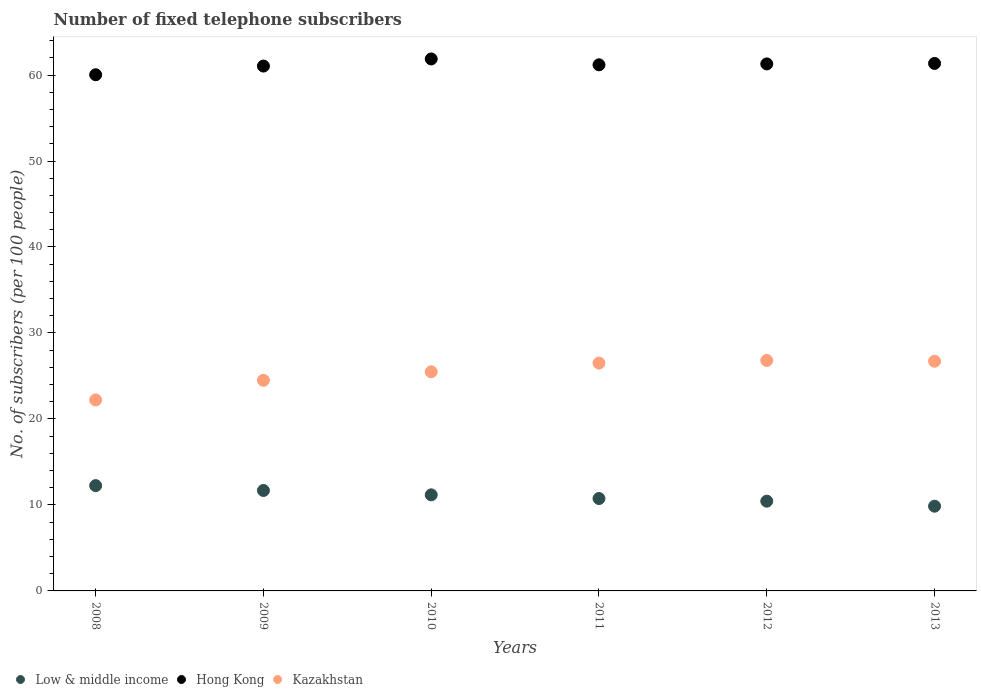What is the number of fixed telephone subscribers in Kazakhstan in 2013?
Your response must be concise. 26.71. Across all years, what is the maximum number of fixed telephone subscribers in Kazakhstan?
Give a very brief answer. 26.8. Across all years, what is the minimum number of fixed telephone subscribers in Kazakhstan?
Provide a succinct answer. 22.21. In which year was the number of fixed telephone subscribers in Low & middle income maximum?
Make the answer very short. 2008. In which year was the number of fixed telephone subscribers in Hong Kong minimum?
Your answer should be compact. 2008. What is the total number of fixed telephone subscribers in Low & middle income in the graph?
Your answer should be very brief. 66.14. What is the difference between the number of fixed telephone subscribers in Low & middle income in 2008 and that in 2009?
Provide a succinct answer. 0.57. What is the difference between the number of fixed telephone subscribers in Hong Kong in 2009 and the number of fixed telephone subscribers in Kazakhstan in 2012?
Make the answer very short. 34.24. What is the average number of fixed telephone subscribers in Low & middle income per year?
Your response must be concise. 11.02. In the year 2008, what is the difference between the number of fixed telephone subscribers in Low & middle income and number of fixed telephone subscribers in Hong Kong?
Provide a succinct answer. -47.79. In how many years, is the number of fixed telephone subscribers in Hong Kong greater than 28?
Your answer should be compact. 6. What is the ratio of the number of fixed telephone subscribers in Hong Kong in 2010 to that in 2013?
Make the answer very short. 1.01. Is the number of fixed telephone subscribers in Hong Kong in 2008 less than that in 2012?
Give a very brief answer. Yes. Is the difference between the number of fixed telephone subscribers in Low & middle income in 2008 and 2013 greater than the difference between the number of fixed telephone subscribers in Hong Kong in 2008 and 2013?
Ensure brevity in your answer.  Yes. What is the difference between the highest and the second highest number of fixed telephone subscribers in Hong Kong?
Your answer should be very brief. 0.52. What is the difference between the highest and the lowest number of fixed telephone subscribers in Hong Kong?
Your answer should be compact. 1.84. In how many years, is the number of fixed telephone subscribers in Hong Kong greater than the average number of fixed telephone subscribers in Hong Kong taken over all years?
Provide a short and direct response. 4. Is the number of fixed telephone subscribers in Hong Kong strictly greater than the number of fixed telephone subscribers in Low & middle income over the years?
Your answer should be compact. Yes. Are the values on the major ticks of Y-axis written in scientific E-notation?
Offer a very short reply. No. Where does the legend appear in the graph?
Your answer should be compact. Bottom left. What is the title of the graph?
Provide a short and direct response. Number of fixed telephone subscribers. Does "United States" appear as one of the legend labels in the graph?
Your response must be concise. No. What is the label or title of the Y-axis?
Provide a short and direct response. No. of subscribers (per 100 people). What is the No. of subscribers (per 100 people) of Low & middle income in 2008?
Give a very brief answer. 12.25. What is the No. of subscribers (per 100 people) of Hong Kong in 2008?
Give a very brief answer. 60.03. What is the No. of subscribers (per 100 people) in Kazakhstan in 2008?
Offer a very short reply. 22.21. What is the No. of subscribers (per 100 people) of Low & middle income in 2009?
Provide a succinct answer. 11.68. What is the No. of subscribers (per 100 people) in Hong Kong in 2009?
Your answer should be compact. 61.04. What is the No. of subscribers (per 100 people) of Kazakhstan in 2009?
Offer a terse response. 24.5. What is the No. of subscribers (per 100 people) of Low & middle income in 2010?
Keep it short and to the point. 11.17. What is the No. of subscribers (per 100 people) of Hong Kong in 2010?
Make the answer very short. 61.87. What is the No. of subscribers (per 100 people) of Kazakhstan in 2010?
Keep it short and to the point. 25.49. What is the No. of subscribers (per 100 people) in Low & middle income in 2011?
Keep it short and to the point. 10.75. What is the No. of subscribers (per 100 people) in Hong Kong in 2011?
Offer a very short reply. 61.19. What is the No. of subscribers (per 100 people) in Kazakhstan in 2011?
Your answer should be compact. 26.5. What is the No. of subscribers (per 100 people) in Low & middle income in 2012?
Offer a terse response. 10.44. What is the No. of subscribers (per 100 people) in Hong Kong in 2012?
Offer a terse response. 61.29. What is the No. of subscribers (per 100 people) in Kazakhstan in 2012?
Your response must be concise. 26.8. What is the No. of subscribers (per 100 people) in Low & middle income in 2013?
Offer a very short reply. 9.85. What is the No. of subscribers (per 100 people) of Hong Kong in 2013?
Make the answer very short. 61.35. What is the No. of subscribers (per 100 people) of Kazakhstan in 2013?
Your answer should be very brief. 26.71. Across all years, what is the maximum No. of subscribers (per 100 people) of Low & middle income?
Keep it short and to the point. 12.25. Across all years, what is the maximum No. of subscribers (per 100 people) of Hong Kong?
Make the answer very short. 61.87. Across all years, what is the maximum No. of subscribers (per 100 people) in Kazakhstan?
Give a very brief answer. 26.8. Across all years, what is the minimum No. of subscribers (per 100 people) in Low & middle income?
Keep it short and to the point. 9.85. Across all years, what is the minimum No. of subscribers (per 100 people) in Hong Kong?
Provide a succinct answer. 60.03. Across all years, what is the minimum No. of subscribers (per 100 people) of Kazakhstan?
Your answer should be very brief. 22.21. What is the total No. of subscribers (per 100 people) in Low & middle income in the graph?
Offer a very short reply. 66.14. What is the total No. of subscribers (per 100 people) of Hong Kong in the graph?
Provide a succinct answer. 366.78. What is the total No. of subscribers (per 100 people) of Kazakhstan in the graph?
Ensure brevity in your answer.  152.21. What is the difference between the No. of subscribers (per 100 people) in Low & middle income in 2008 and that in 2009?
Provide a succinct answer. 0.57. What is the difference between the No. of subscribers (per 100 people) of Hong Kong in 2008 and that in 2009?
Make the answer very short. -1.01. What is the difference between the No. of subscribers (per 100 people) of Kazakhstan in 2008 and that in 2009?
Make the answer very short. -2.28. What is the difference between the No. of subscribers (per 100 people) of Low & middle income in 2008 and that in 2010?
Provide a succinct answer. 1.07. What is the difference between the No. of subscribers (per 100 people) of Hong Kong in 2008 and that in 2010?
Give a very brief answer. -1.84. What is the difference between the No. of subscribers (per 100 people) in Kazakhstan in 2008 and that in 2010?
Your answer should be compact. -3.27. What is the difference between the No. of subscribers (per 100 people) in Low & middle income in 2008 and that in 2011?
Your response must be concise. 1.5. What is the difference between the No. of subscribers (per 100 people) in Hong Kong in 2008 and that in 2011?
Make the answer very short. -1.16. What is the difference between the No. of subscribers (per 100 people) of Kazakhstan in 2008 and that in 2011?
Provide a succinct answer. -4.28. What is the difference between the No. of subscribers (per 100 people) of Low & middle income in 2008 and that in 2012?
Offer a very short reply. 1.81. What is the difference between the No. of subscribers (per 100 people) in Hong Kong in 2008 and that in 2012?
Give a very brief answer. -1.26. What is the difference between the No. of subscribers (per 100 people) in Kazakhstan in 2008 and that in 2012?
Keep it short and to the point. -4.59. What is the difference between the No. of subscribers (per 100 people) of Low & middle income in 2008 and that in 2013?
Provide a short and direct response. 2.39. What is the difference between the No. of subscribers (per 100 people) in Hong Kong in 2008 and that in 2013?
Offer a very short reply. -1.32. What is the difference between the No. of subscribers (per 100 people) of Kazakhstan in 2008 and that in 2013?
Your response must be concise. -4.5. What is the difference between the No. of subscribers (per 100 people) of Low & middle income in 2009 and that in 2010?
Your response must be concise. 0.51. What is the difference between the No. of subscribers (per 100 people) of Hong Kong in 2009 and that in 2010?
Provide a succinct answer. -0.83. What is the difference between the No. of subscribers (per 100 people) of Kazakhstan in 2009 and that in 2010?
Keep it short and to the point. -0.99. What is the difference between the No. of subscribers (per 100 people) of Low & middle income in 2009 and that in 2011?
Your response must be concise. 0.93. What is the difference between the No. of subscribers (per 100 people) in Hong Kong in 2009 and that in 2011?
Provide a succinct answer. -0.15. What is the difference between the No. of subscribers (per 100 people) of Kazakhstan in 2009 and that in 2011?
Keep it short and to the point. -2. What is the difference between the No. of subscribers (per 100 people) of Low & middle income in 2009 and that in 2012?
Offer a terse response. 1.24. What is the difference between the No. of subscribers (per 100 people) of Hong Kong in 2009 and that in 2012?
Your answer should be very brief. -0.25. What is the difference between the No. of subscribers (per 100 people) in Kazakhstan in 2009 and that in 2012?
Your response must be concise. -2.31. What is the difference between the No. of subscribers (per 100 people) in Low & middle income in 2009 and that in 2013?
Offer a very short reply. 1.83. What is the difference between the No. of subscribers (per 100 people) of Hong Kong in 2009 and that in 2013?
Give a very brief answer. -0.3. What is the difference between the No. of subscribers (per 100 people) of Kazakhstan in 2009 and that in 2013?
Provide a short and direct response. -2.22. What is the difference between the No. of subscribers (per 100 people) in Low & middle income in 2010 and that in 2011?
Your answer should be very brief. 0.43. What is the difference between the No. of subscribers (per 100 people) of Hong Kong in 2010 and that in 2011?
Give a very brief answer. 0.68. What is the difference between the No. of subscribers (per 100 people) of Kazakhstan in 2010 and that in 2011?
Ensure brevity in your answer.  -1.01. What is the difference between the No. of subscribers (per 100 people) of Low & middle income in 2010 and that in 2012?
Keep it short and to the point. 0.73. What is the difference between the No. of subscribers (per 100 people) of Hong Kong in 2010 and that in 2012?
Offer a terse response. 0.58. What is the difference between the No. of subscribers (per 100 people) in Kazakhstan in 2010 and that in 2012?
Your response must be concise. -1.32. What is the difference between the No. of subscribers (per 100 people) of Low & middle income in 2010 and that in 2013?
Offer a terse response. 1.32. What is the difference between the No. of subscribers (per 100 people) of Hong Kong in 2010 and that in 2013?
Provide a succinct answer. 0.52. What is the difference between the No. of subscribers (per 100 people) of Kazakhstan in 2010 and that in 2013?
Provide a succinct answer. -1.23. What is the difference between the No. of subscribers (per 100 people) of Low & middle income in 2011 and that in 2012?
Offer a terse response. 0.31. What is the difference between the No. of subscribers (per 100 people) of Hong Kong in 2011 and that in 2012?
Offer a very short reply. -0.1. What is the difference between the No. of subscribers (per 100 people) of Kazakhstan in 2011 and that in 2012?
Provide a short and direct response. -0.31. What is the difference between the No. of subscribers (per 100 people) of Low & middle income in 2011 and that in 2013?
Provide a succinct answer. 0.89. What is the difference between the No. of subscribers (per 100 people) in Hong Kong in 2011 and that in 2013?
Make the answer very short. -0.16. What is the difference between the No. of subscribers (per 100 people) of Kazakhstan in 2011 and that in 2013?
Offer a very short reply. -0.22. What is the difference between the No. of subscribers (per 100 people) of Low & middle income in 2012 and that in 2013?
Keep it short and to the point. 0.58. What is the difference between the No. of subscribers (per 100 people) of Hong Kong in 2012 and that in 2013?
Your answer should be compact. -0.05. What is the difference between the No. of subscribers (per 100 people) of Kazakhstan in 2012 and that in 2013?
Provide a succinct answer. 0.09. What is the difference between the No. of subscribers (per 100 people) in Low & middle income in 2008 and the No. of subscribers (per 100 people) in Hong Kong in 2009?
Your answer should be compact. -48.8. What is the difference between the No. of subscribers (per 100 people) in Low & middle income in 2008 and the No. of subscribers (per 100 people) in Kazakhstan in 2009?
Make the answer very short. -12.25. What is the difference between the No. of subscribers (per 100 people) of Hong Kong in 2008 and the No. of subscribers (per 100 people) of Kazakhstan in 2009?
Make the answer very short. 35.54. What is the difference between the No. of subscribers (per 100 people) in Low & middle income in 2008 and the No. of subscribers (per 100 people) in Hong Kong in 2010?
Ensure brevity in your answer.  -49.63. What is the difference between the No. of subscribers (per 100 people) of Low & middle income in 2008 and the No. of subscribers (per 100 people) of Kazakhstan in 2010?
Ensure brevity in your answer.  -13.24. What is the difference between the No. of subscribers (per 100 people) in Hong Kong in 2008 and the No. of subscribers (per 100 people) in Kazakhstan in 2010?
Offer a terse response. 34.55. What is the difference between the No. of subscribers (per 100 people) of Low & middle income in 2008 and the No. of subscribers (per 100 people) of Hong Kong in 2011?
Provide a succinct answer. -48.94. What is the difference between the No. of subscribers (per 100 people) of Low & middle income in 2008 and the No. of subscribers (per 100 people) of Kazakhstan in 2011?
Your answer should be compact. -14.25. What is the difference between the No. of subscribers (per 100 people) of Hong Kong in 2008 and the No. of subscribers (per 100 people) of Kazakhstan in 2011?
Your answer should be compact. 33.53. What is the difference between the No. of subscribers (per 100 people) of Low & middle income in 2008 and the No. of subscribers (per 100 people) of Hong Kong in 2012?
Your answer should be compact. -49.05. What is the difference between the No. of subscribers (per 100 people) of Low & middle income in 2008 and the No. of subscribers (per 100 people) of Kazakhstan in 2012?
Your answer should be very brief. -14.56. What is the difference between the No. of subscribers (per 100 people) of Hong Kong in 2008 and the No. of subscribers (per 100 people) of Kazakhstan in 2012?
Make the answer very short. 33.23. What is the difference between the No. of subscribers (per 100 people) in Low & middle income in 2008 and the No. of subscribers (per 100 people) in Hong Kong in 2013?
Ensure brevity in your answer.  -49.1. What is the difference between the No. of subscribers (per 100 people) of Low & middle income in 2008 and the No. of subscribers (per 100 people) of Kazakhstan in 2013?
Offer a terse response. -14.47. What is the difference between the No. of subscribers (per 100 people) of Hong Kong in 2008 and the No. of subscribers (per 100 people) of Kazakhstan in 2013?
Offer a terse response. 33.32. What is the difference between the No. of subscribers (per 100 people) in Low & middle income in 2009 and the No. of subscribers (per 100 people) in Hong Kong in 2010?
Your response must be concise. -50.19. What is the difference between the No. of subscribers (per 100 people) of Low & middle income in 2009 and the No. of subscribers (per 100 people) of Kazakhstan in 2010?
Provide a succinct answer. -13.8. What is the difference between the No. of subscribers (per 100 people) in Hong Kong in 2009 and the No. of subscribers (per 100 people) in Kazakhstan in 2010?
Provide a short and direct response. 35.56. What is the difference between the No. of subscribers (per 100 people) of Low & middle income in 2009 and the No. of subscribers (per 100 people) of Hong Kong in 2011?
Your answer should be very brief. -49.51. What is the difference between the No. of subscribers (per 100 people) of Low & middle income in 2009 and the No. of subscribers (per 100 people) of Kazakhstan in 2011?
Ensure brevity in your answer.  -14.82. What is the difference between the No. of subscribers (per 100 people) of Hong Kong in 2009 and the No. of subscribers (per 100 people) of Kazakhstan in 2011?
Provide a succinct answer. 34.54. What is the difference between the No. of subscribers (per 100 people) of Low & middle income in 2009 and the No. of subscribers (per 100 people) of Hong Kong in 2012?
Make the answer very short. -49.61. What is the difference between the No. of subscribers (per 100 people) in Low & middle income in 2009 and the No. of subscribers (per 100 people) in Kazakhstan in 2012?
Your answer should be compact. -15.12. What is the difference between the No. of subscribers (per 100 people) of Hong Kong in 2009 and the No. of subscribers (per 100 people) of Kazakhstan in 2012?
Give a very brief answer. 34.24. What is the difference between the No. of subscribers (per 100 people) of Low & middle income in 2009 and the No. of subscribers (per 100 people) of Hong Kong in 2013?
Give a very brief answer. -49.67. What is the difference between the No. of subscribers (per 100 people) of Low & middle income in 2009 and the No. of subscribers (per 100 people) of Kazakhstan in 2013?
Give a very brief answer. -15.03. What is the difference between the No. of subscribers (per 100 people) in Hong Kong in 2009 and the No. of subscribers (per 100 people) in Kazakhstan in 2013?
Ensure brevity in your answer.  34.33. What is the difference between the No. of subscribers (per 100 people) in Low & middle income in 2010 and the No. of subscribers (per 100 people) in Hong Kong in 2011?
Ensure brevity in your answer.  -50.02. What is the difference between the No. of subscribers (per 100 people) of Low & middle income in 2010 and the No. of subscribers (per 100 people) of Kazakhstan in 2011?
Give a very brief answer. -15.32. What is the difference between the No. of subscribers (per 100 people) of Hong Kong in 2010 and the No. of subscribers (per 100 people) of Kazakhstan in 2011?
Make the answer very short. 35.37. What is the difference between the No. of subscribers (per 100 people) of Low & middle income in 2010 and the No. of subscribers (per 100 people) of Hong Kong in 2012?
Make the answer very short. -50.12. What is the difference between the No. of subscribers (per 100 people) of Low & middle income in 2010 and the No. of subscribers (per 100 people) of Kazakhstan in 2012?
Your response must be concise. -15.63. What is the difference between the No. of subscribers (per 100 people) in Hong Kong in 2010 and the No. of subscribers (per 100 people) in Kazakhstan in 2012?
Give a very brief answer. 35.07. What is the difference between the No. of subscribers (per 100 people) in Low & middle income in 2010 and the No. of subscribers (per 100 people) in Hong Kong in 2013?
Your response must be concise. -50.17. What is the difference between the No. of subscribers (per 100 people) in Low & middle income in 2010 and the No. of subscribers (per 100 people) in Kazakhstan in 2013?
Your answer should be very brief. -15.54. What is the difference between the No. of subscribers (per 100 people) in Hong Kong in 2010 and the No. of subscribers (per 100 people) in Kazakhstan in 2013?
Your answer should be very brief. 35.16. What is the difference between the No. of subscribers (per 100 people) in Low & middle income in 2011 and the No. of subscribers (per 100 people) in Hong Kong in 2012?
Your answer should be compact. -50.55. What is the difference between the No. of subscribers (per 100 people) of Low & middle income in 2011 and the No. of subscribers (per 100 people) of Kazakhstan in 2012?
Make the answer very short. -16.06. What is the difference between the No. of subscribers (per 100 people) in Hong Kong in 2011 and the No. of subscribers (per 100 people) in Kazakhstan in 2012?
Your answer should be compact. 34.39. What is the difference between the No. of subscribers (per 100 people) in Low & middle income in 2011 and the No. of subscribers (per 100 people) in Hong Kong in 2013?
Provide a short and direct response. -50.6. What is the difference between the No. of subscribers (per 100 people) in Low & middle income in 2011 and the No. of subscribers (per 100 people) in Kazakhstan in 2013?
Ensure brevity in your answer.  -15.97. What is the difference between the No. of subscribers (per 100 people) of Hong Kong in 2011 and the No. of subscribers (per 100 people) of Kazakhstan in 2013?
Your answer should be very brief. 34.48. What is the difference between the No. of subscribers (per 100 people) of Low & middle income in 2012 and the No. of subscribers (per 100 people) of Hong Kong in 2013?
Your response must be concise. -50.91. What is the difference between the No. of subscribers (per 100 people) of Low & middle income in 2012 and the No. of subscribers (per 100 people) of Kazakhstan in 2013?
Offer a terse response. -16.28. What is the difference between the No. of subscribers (per 100 people) of Hong Kong in 2012 and the No. of subscribers (per 100 people) of Kazakhstan in 2013?
Keep it short and to the point. 34.58. What is the average No. of subscribers (per 100 people) of Low & middle income per year?
Keep it short and to the point. 11.02. What is the average No. of subscribers (per 100 people) in Hong Kong per year?
Provide a succinct answer. 61.13. What is the average No. of subscribers (per 100 people) of Kazakhstan per year?
Make the answer very short. 25.37. In the year 2008, what is the difference between the No. of subscribers (per 100 people) in Low & middle income and No. of subscribers (per 100 people) in Hong Kong?
Offer a very short reply. -47.79. In the year 2008, what is the difference between the No. of subscribers (per 100 people) in Low & middle income and No. of subscribers (per 100 people) in Kazakhstan?
Provide a succinct answer. -9.97. In the year 2008, what is the difference between the No. of subscribers (per 100 people) of Hong Kong and No. of subscribers (per 100 people) of Kazakhstan?
Keep it short and to the point. 37.82. In the year 2009, what is the difference between the No. of subscribers (per 100 people) in Low & middle income and No. of subscribers (per 100 people) in Hong Kong?
Make the answer very short. -49.36. In the year 2009, what is the difference between the No. of subscribers (per 100 people) of Low & middle income and No. of subscribers (per 100 people) of Kazakhstan?
Give a very brief answer. -12.81. In the year 2009, what is the difference between the No. of subscribers (per 100 people) of Hong Kong and No. of subscribers (per 100 people) of Kazakhstan?
Your response must be concise. 36.55. In the year 2010, what is the difference between the No. of subscribers (per 100 people) in Low & middle income and No. of subscribers (per 100 people) in Hong Kong?
Your answer should be very brief. -50.7. In the year 2010, what is the difference between the No. of subscribers (per 100 people) in Low & middle income and No. of subscribers (per 100 people) in Kazakhstan?
Your response must be concise. -14.31. In the year 2010, what is the difference between the No. of subscribers (per 100 people) in Hong Kong and No. of subscribers (per 100 people) in Kazakhstan?
Ensure brevity in your answer.  36.39. In the year 2011, what is the difference between the No. of subscribers (per 100 people) of Low & middle income and No. of subscribers (per 100 people) of Hong Kong?
Offer a terse response. -50.44. In the year 2011, what is the difference between the No. of subscribers (per 100 people) in Low & middle income and No. of subscribers (per 100 people) in Kazakhstan?
Your answer should be very brief. -15.75. In the year 2011, what is the difference between the No. of subscribers (per 100 people) in Hong Kong and No. of subscribers (per 100 people) in Kazakhstan?
Provide a succinct answer. 34.69. In the year 2012, what is the difference between the No. of subscribers (per 100 people) of Low & middle income and No. of subscribers (per 100 people) of Hong Kong?
Your response must be concise. -50.85. In the year 2012, what is the difference between the No. of subscribers (per 100 people) in Low & middle income and No. of subscribers (per 100 people) in Kazakhstan?
Your answer should be very brief. -16.37. In the year 2012, what is the difference between the No. of subscribers (per 100 people) of Hong Kong and No. of subscribers (per 100 people) of Kazakhstan?
Offer a terse response. 34.49. In the year 2013, what is the difference between the No. of subscribers (per 100 people) in Low & middle income and No. of subscribers (per 100 people) in Hong Kong?
Provide a short and direct response. -51.49. In the year 2013, what is the difference between the No. of subscribers (per 100 people) in Low & middle income and No. of subscribers (per 100 people) in Kazakhstan?
Offer a very short reply. -16.86. In the year 2013, what is the difference between the No. of subscribers (per 100 people) of Hong Kong and No. of subscribers (per 100 people) of Kazakhstan?
Your answer should be very brief. 34.63. What is the ratio of the No. of subscribers (per 100 people) in Low & middle income in 2008 to that in 2009?
Offer a very short reply. 1.05. What is the ratio of the No. of subscribers (per 100 people) in Hong Kong in 2008 to that in 2009?
Give a very brief answer. 0.98. What is the ratio of the No. of subscribers (per 100 people) in Kazakhstan in 2008 to that in 2009?
Your answer should be compact. 0.91. What is the ratio of the No. of subscribers (per 100 people) of Low & middle income in 2008 to that in 2010?
Provide a short and direct response. 1.1. What is the ratio of the No. of subscribers (per 100 people) of Hong Kong in 2008 to that in 2010?
Provide a short and direct response. 0.97. What is the ratio of the No. of subscribers (per 100 people) in Kazakhstan in 2008 to that in 2010?
Give a very brief answer. 0.87. What is the ratio of the No. of subscribers (per 100 people) of Low & middle income in 2008 to that in 2011?
Provide a short and direct response. 1.14. What is the ratio of the No. of subscribers (per 100 people) of Hong Kong in 2008 to that in 2011?
Make the answer very short. 0.98. What is the ratio of the No. of subscribers (per 100 people) in Kazakhstan in 2008 to that in 2011?
Ensure brevity in your answer.  0.84. What is the ratio of the No. of subscribers (per 100 people) in Low & middle income in 2008 to that in 2012?
Keep it short and to the point. 1.17. What is the ratio of the No. of subscribers (per 100 people) in Hong Kong in 2008 to that in 2012?
Give a very brief answer. 0.98. What is the ratio of the No. of subscribers (per 100 people) of Kazakhstan in 2008 to that in 2012?
Keep it short and to the point. 0.83. What is the ratio of the No. of subscribers (per 100 people) in Low & middle income in 2008 to that in 2013?
Your answer should be very brief. 1.24. What is the ratio of the No. of subscribers (per 100 people) in Hong Kong in 2008 to that in 2013?
Your answer should be very brief. 0.98. What is the ratio of the No. of subscribers (per 100 people) of Kazakhstan in 2008 to that in 2013?
Make the answer very short. 0.83. What is the ratio of the No. of subscribers (per 100 people) in Low & middle income in 2009 to that in 2010?
Offer a terse response. 1.05. What is the ratio of the No. of subscribers (per 100 people) of Hong Kong in 2009 to that in 2010?
Provide a short and direct response. 0.99. What is the ratio of the No. of subscribers (per 100 people) in Kazakhstan in 2009 to that in 2010?
Your answer should be compact. 0.96. What is the ratio of the No. of subscribers (per 100 people) in Low & middle income in 2009 to that in 2011?
Provide a short and direct response. 1.09. What is the ratio of the No. of subscribers (per 100 people) of Kazakhstan in 2009 to that in 2011?
Make the answer very short. 0.92. What is the ratio of the No. of subscribers (per 100 people) in Low & middle income in 2009 to that in 2012?
Give a very brief answer. 1.12. What is the ratio of the No. of subscribers (per 100 people) in Kazakhstan in 2009 to that in 2012?
Offer a terse response. 0.91. What is the ratio of the No. of subscribers (per 100 people) of Low & middle income in 2009 to that in 2013?
Offer a very short reply. 1.19. What is the ratio of the No. of subscribers (per 100 people) of Kazakhstan in 2009 to that in 2013?
Give a very brief answer. 0.92. What is the ratio of the No. of subscribers (per 100 people) of Low & middle income in 2010 to that in 2011?
Your response must be concise. 1.04. What is the ratio of the No. of subscribers (per 100 people) in Hong Kong in 2010 to that in 2011?
Offer a very short reply. 1.01. What is the ratio of the No. of subscribers (per 100 people) of Kazakhstan in 2010 to that in 2011?
Your answer should be compact. 0.96. What is the ratio of the No. of subscribers (per 100 people) in Low & middle income in 2010 to that in 2012?
Your response must be concise. 1.07. What is the ratio of the No. of subscribers (per 100 people) in Hong Kong in 2010 to that in 2012?
Your answer should be compact. 1.01. What is the ratio of the No. of subscribers (per 100 people) of Kazakhstan in 2010 to that in 2012?
Your answer should be very brief. 0.95. What is the ratio of the No. of subscribers (per 100 people) of Low & middle income in 2010 to that in 2013?
Your answer should be compact. 1.13. What is the ratio of the No. of subscribers (per 100 people) in Hong Kong in 2010 to that in 2013?
Make the answer very short. 1.01. What is the ratio of the No. of subscribers (per 100 people) of Kazakhstan in 2010 to that in 2013?
Make the answer very short. 0.95. What is the ratio of the No. of subscribers (per 100 people) of Low & middle income in 2011 to that in 2012?
Give a very brief answer. 1.03. What is the ratio of the No. of subscribers (per 100 people) of Kazakhstan in 2011 to that in 2012?
Offer a very short reply. 0.99. What is the ratio of the No. of subscribers (per 100 people) of Low & middle income in 2011 to that in 2013?
Ensure brevity in your answer.  1.09. What is the ratio of the No. of subscribers (per 100 people) of Kazakhstan in 2011 to that in 2013?
Offer a very short reply. 0.99. What is the ratio of the No. of subscribers (per 100 people) in Low & middle income in 2012 to that in 2013?
Your answer should be very brief. 1.06. What is the ratio of the No. of subscribers (per 100 people) of Hong Kong in 2012 to that in 2013?
Ensure brevity in your answer.  1. What is the difference between the highest and the second highest No. of subscribers (per 100 people) in Low & middle income?
Make the answer very short. 0.57. What is the difference between the highest and the second highest No. of subscribers (per 100 people) of Hong Kong?
Give a very brief answer. 0.52. What is the difference between the highest and the second highest No. of subscribers (per 100 people) of Kazakhstan?
Your answer should be compact. 0.09. What is the difference between the highest and the lowest No. of subscribers (per 100 people) in Low & middle income?
Provide a succinct answer. 2.39. What is the difference between the highest and the lowest No. of subscribers (per 100 people) in Hong Kong?
Offer a terse response. 1.84. What is the difference between the highest and the lowest No. of subscribers (per 100 people) in Kazakhstan?
Your answer should be very brief. 4.59. 